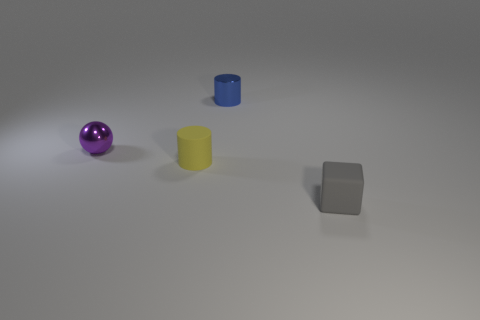What could be the possible uses of these objects? These objects could be used in a variety of educational or illustrative settings. The sphere, cylinder, and cube might be part of a geometry learning kit, demonstrating 3D shapes. Alternatively, they could serve as minimalist decor items, adding a modern touch to a space with their simple forms and bold colors. Are these objects large enough to hold in one hand? Without reference for scale in the image, it's challenging to precisely assess their size. However, if I were to estimate based on the apparent proximity of the objects to each other, I would say they are likely small enough to be held in one hand. 